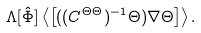<formula> <loc_0><loc_0><loc_500><loc_500>\Lambda [ \hat { \Phi } ] \left < \left [ ( ( C ^ { \Theta \Theta } ) ^ { - 1 } \Theta ) \nabla \Theta \right ] \right > .</formula> 